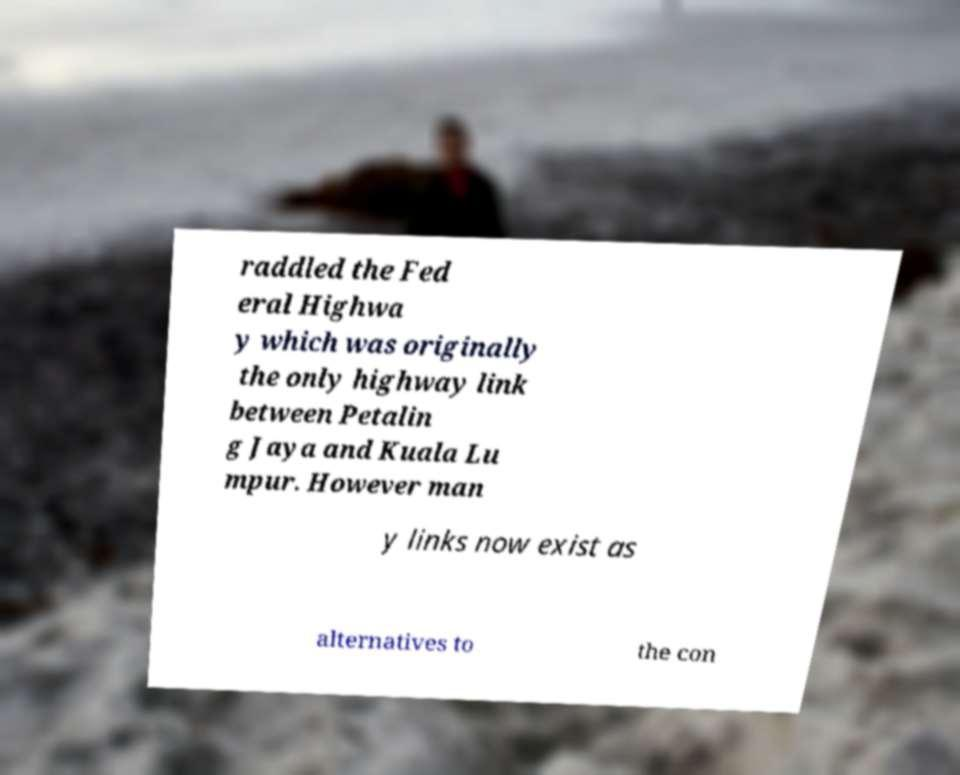For documentation purposes, I need the text within this image transcribed. Could you provide that? raddled the Fed eral Highwa y which was originally the only highway link between Petalin g Jaya and Kuala Lu mpur. However man y links now exist as alternatives to the con 